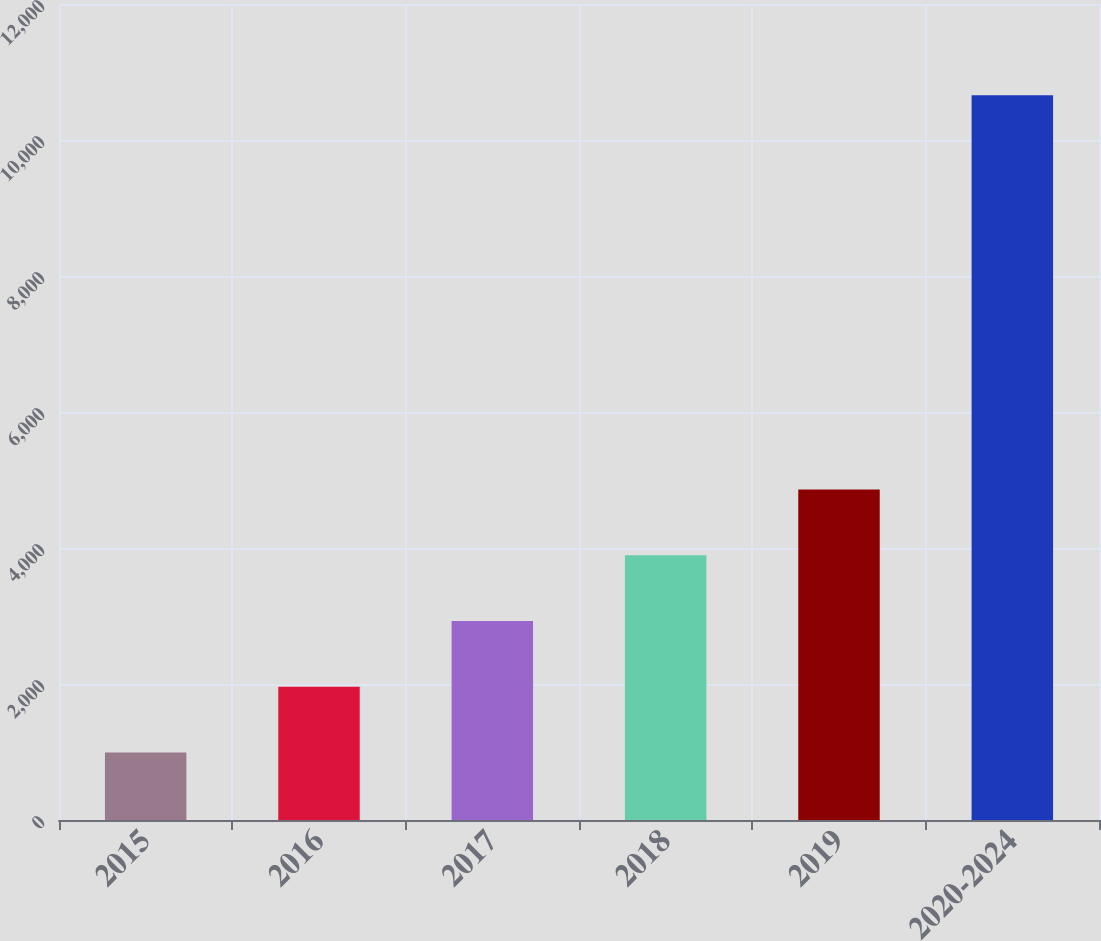Convert chart. <chart><loc_0><loc_0><loc_500><loc_500><bar_chart><fcel>2015<fcel>2016<fcel>2017<fcel>2018<fcel>2019<fcel>2020-2024<nl><fcel>994<fcel>1960.5<fcel>2927<fcel>3893.5<fcel>4860<fcel>10659<nl></chart> 